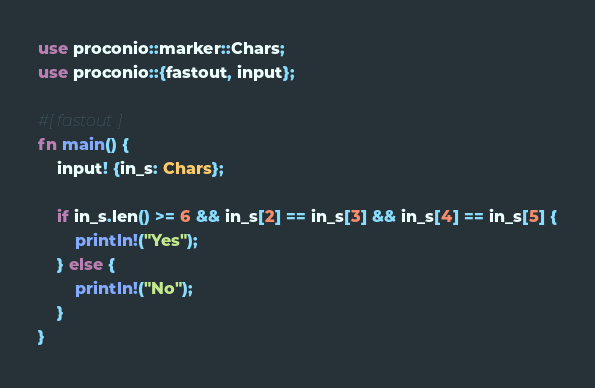Convert code to text. <code><loc_0><loc_0><loc_500><loc_500><_Rust_>use proconio::marker::Chars;
use proconio::{fastout, input};

#[fastout]
fn main() {
    input! {in_s: Chars};

    if in_s.len() >= 6 && in_s[2] == in_s[3] && in_s[4] == in_s[5] {
        println!("Yes");
    } else {
        println!("No");
    }
}
</code> 